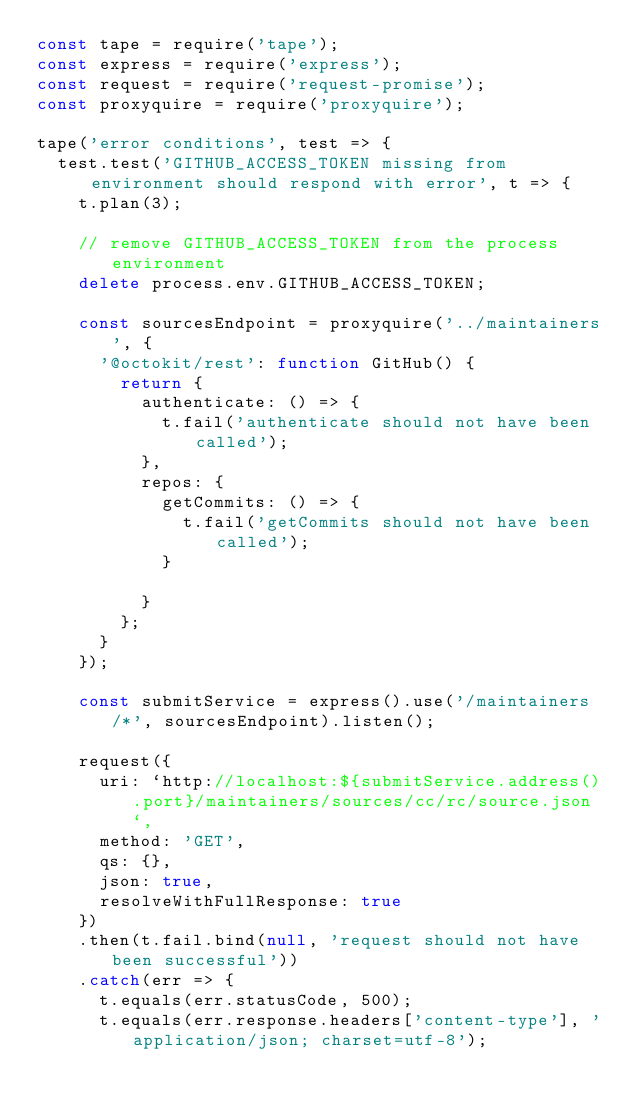<code> <loc_0><loc_0><loc_500><loc_500><_JavaScript_>const tape = require('tape');
const express = require('express');
const request = require('request-promise');
const proxyquire = require('proxyquire');

tape('error conditions', test => {
  test.test('GITHUB_ACCESS_TOKEN missing from environment should respond with error', t => {
    t.plan(3);

    // remove GITHUB_ACCESS_TOKEN from the process environment
    delete process.env.GITHUB_ACCESS_TOKEN;

    const sourcesEndpoint = proxyquire('../maintainers', {
      '@octokit/rest': function GitHub() {
        return {
          authenticate: () => {
            t.fail('authenticate should not have been called');
          },
          repos: {
            getCommits: () => {
              t.fail('getCommits should not have been called');
            }

          }
        };
      }
    });

    const submitService = express().use('/maintainers/*', sourcesEndpoint).listen();

    request({
      uri: `http://localhost:${submitService.address().port}/maintainers/sources/cc/rc/source.json`,
      method: 'GET',
      qs: {},
      json: true,
      resolveWithFullResponse: true
    })
    .then(t.fail.bind(null, 'request should not have been successful'))
    .catch(err => {
      t.equals(err.statusCode, 500);
      t.equals(err.response.headers['content-type'], 'application/json; charset=utf-8');</code> 